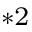Convert formula to latex. <formula><loc_0><loc_0><loc_500><loc_500>^ { * 2 }</formula> 